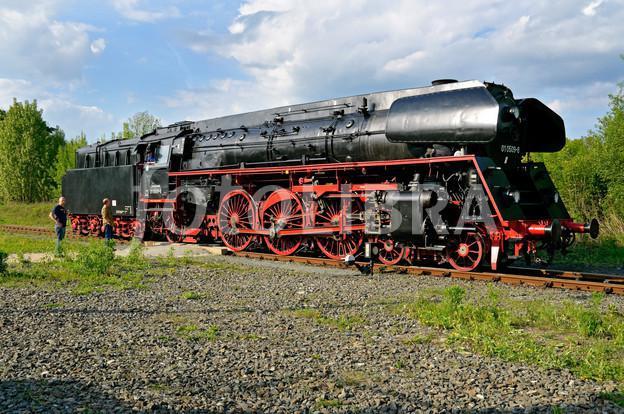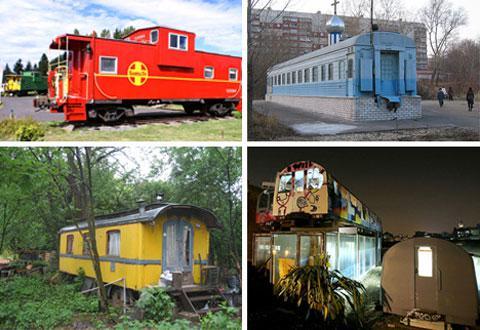The first image is the image on the left, the second image is the image on the right. Considering the images on both sides, is "The train in one of the images is black with red rims." valid? Answer yes or no. Yes. The first image is the image on the left, the second image is the image on the right. Assess this claim about the two images: "Each image includes one predominantly red train on a track.". Correct or not? Answer yes or no. No. 